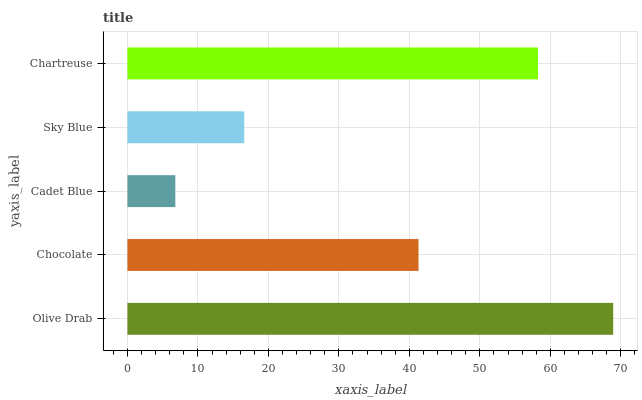Is Cadet Blue the minimum?
Answer yes or no. Yes. Is Olive Drab the maximum?
Answer yes or no. Yes. Is Chocolate the minimum?
Answer yes or no. No. Is Chocolate the maximum?
Answer yes or no. No. Is Olive Drab greater than Chocolate?
Answer yes or no. Yes. Is Chocolate less than Olive Drab?
Answer yes or no. Yes. Is Chocolate greater than Olive Drab?
Answer yes or no. No. Is Olive Drab less than Chocolate?
Answer yes or no. No. Is Chocolate the high median?
Answer yes or no. Yes. Is Chocolate the low median?
Answer yes or no. Yes. Is Olive Drab the high median?
Answer yes or no. No. Is Olive Drab the low median?
Answer yes or no. No. 